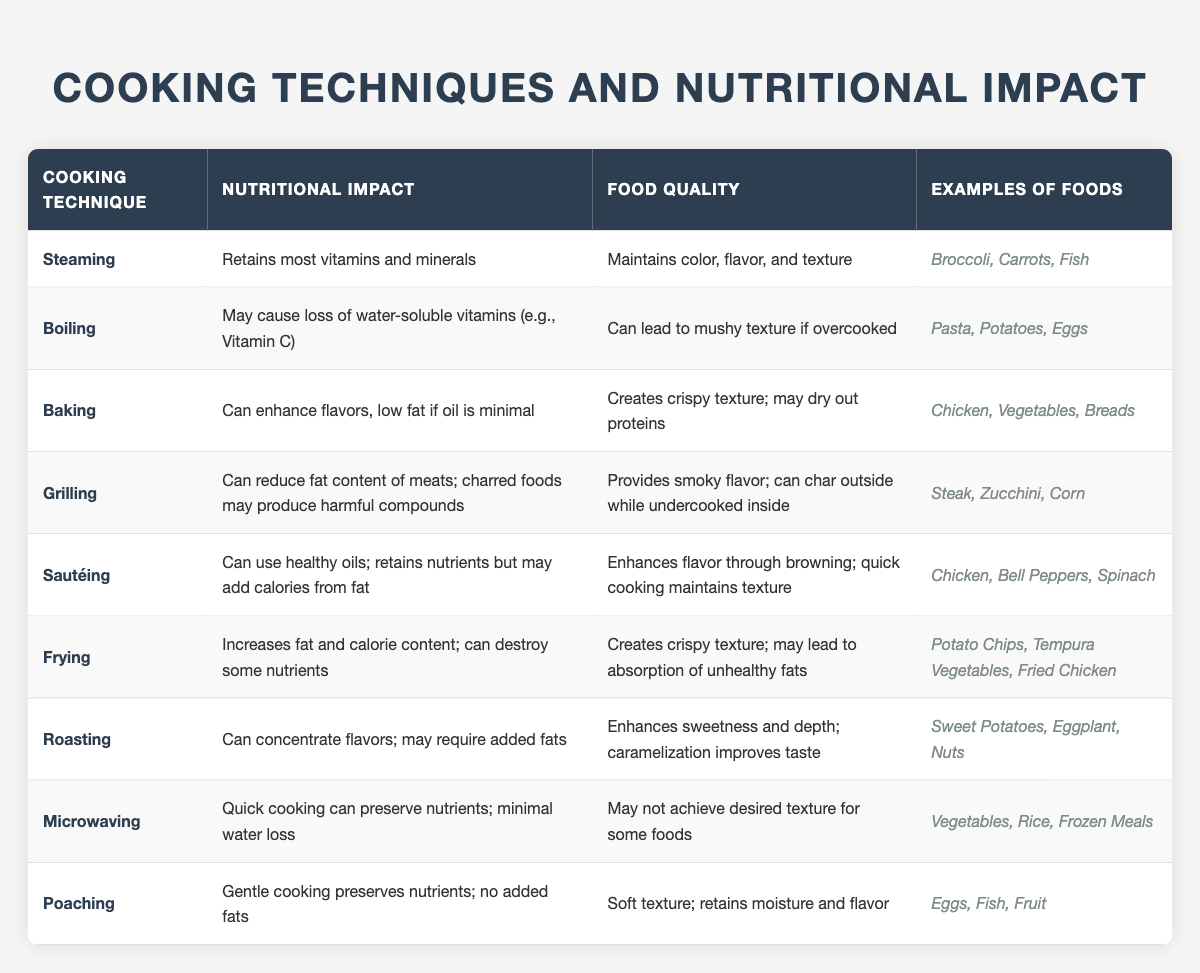What cooking technique retains most vitamins and minerals? The table lists "Steaming" under the Cooking Technique column, and its corresponding Nutritional Impact states that it "Retains most vitamins and minerals."
Answer: Steaming Which cooking methods may cause a loss of water-soluble vitamins? The table shows that "Boiling" can lead to a loss of water-soluble vitamins, such as Vitamin C, as mentioned in the Nutritional Impact column.
Answer: Boiling What are some examples of foods that can be grilled? According to the table, "Grilling" includes examples such as Steak, Zucchini, and Corn in the Examples of Foods column.
Answer: Steak, Zucchini, Corn Does frying increase the calorie content of food? The Nutritional Impact for "Frying" indicates it "Increases fat and calorie content," confirming that frying does indeed increase calories.
Answer: Yes Which technique creates a crispy texture but may lead to absorption of unhealthy fats? The table states that "Frying" creates a crispy texture and mentions the risk of absorbing unhealthy fats in the Food Quality section.
Answer: Frying What cooking method provides a soft texture while retaining moisture and flavor? The Nutritional Impact for "Poaching" states it preserves nutrients and has a soft texture, indicating it retains moisture and flavor.
Answer: Poaching How does microwaving impact nutrient preservation compared to boiling? Microwaving preserves nutrients and has minimal water loss, while boiling can cause a loss of water-soluble vitamins, highlighting that microwaving has an advantage in nutrient preservation.
Answer: Microwaving Which cooking techniques enhance flavor through browning? The table notes that "Sautéing" enhances flavor through browning, which is mentioned in its Food Quality description.
Answer: Sautéing What is the food quality impact of roasting? The table describes that "Roasting" enhances sweetness and depth and that caramelization improves taste, indicating a positive food quality impact.
Answer: Enhances sweetness and depth Which cooking techniques do not require added fats? Both "Steaming" and "Poaching" are mentioned in the Nutritional Impact that they do not require added fats, offering a healthier cooking option.
Answer: Steaming, Poaching 